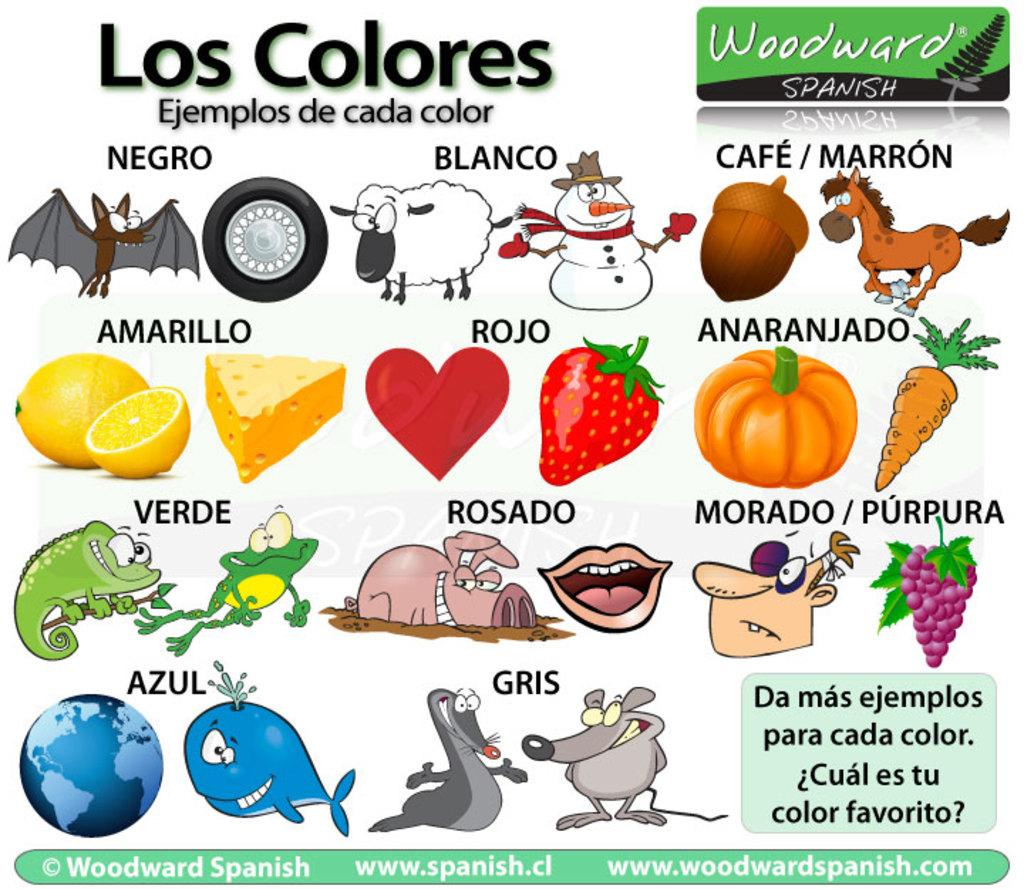What is present on the poster in the picture? There is a poster in the picture, with words and images on it. Can you describe the content of the poster? The poster contains both words and images. What type of card is being used to hold the poster in the image? There is no card present in the image; the poster is not being held by any card. 